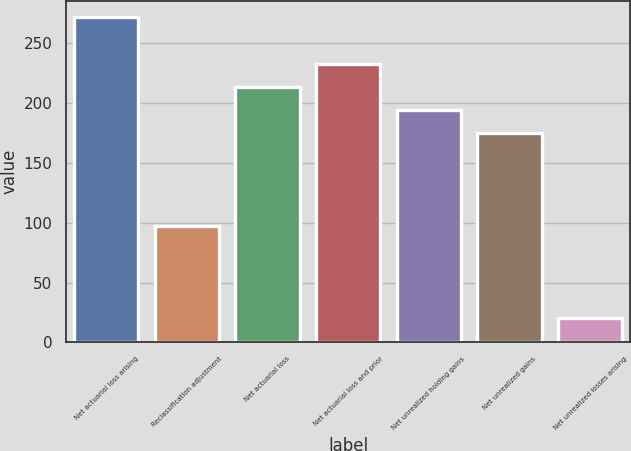<chart> <loc_0><loc_0><loc_500><loc_500><bar_chart><fcel>Net actuarial loss arising<fcel>Reclassification adjustment<fcel>Net actuarial loss<fcel>Net actuarial loss and prior<fcel>Net unrealized holding gains<fcel>Net unrealized gains<fcel>Net unrealized losses arising<nl><fcel>271.88<fcel>97.55<fcel>213.77<fcel>233.14<fcel>194.4<fcel>175.03<fcel>20.07<nl></chart> 